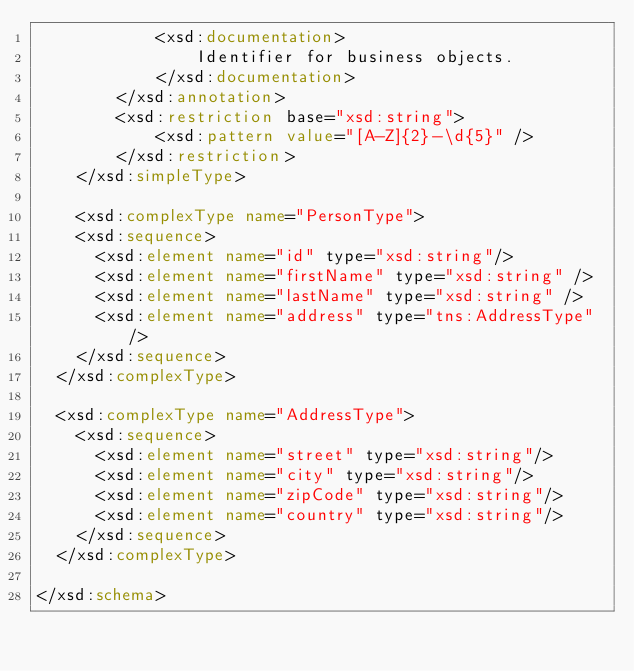Convert code to text. <code><loc_0><loc_0><loc_500><loc_500><_XML_>            <xsd:documentation>
                Identifier for business objects.
            </xsd:documentation>
        </xsd:annotation>
        <xsd:restriction base="xsd:string">
            <xsd:pattern value="[A-Z]{2}-\d{5}" />
        </xsd:restriction>
    </xsd:simpleType>

    <xsd:complexType name="PersonType">
		<xsd:sequence>
			<xsd:element name="id" type="xsd:string"/>
			<xsd:element name="firstName" type="xsd:string" />
			<xsd:element name="lastName" type="xsd:string" />
			<xsd:element name="address" type="tns:AddressType"/>
		</xsd:sequence>
	</xsd:complexType>

	<xsd:complexType name="AddressType">
    <xsd:sequence>
      <xsd:element name="street" type="xsd:string"/>
      <xsd:element name="city" type="xsd:string"/>
      <xsd:element name="zipCode" type="xsd:string"/>
      <xsd:element name="country" type="xsd:string"/>
    </xsd:sequence>
	</xsd:complexType>

</xsd:schema>
</code> 